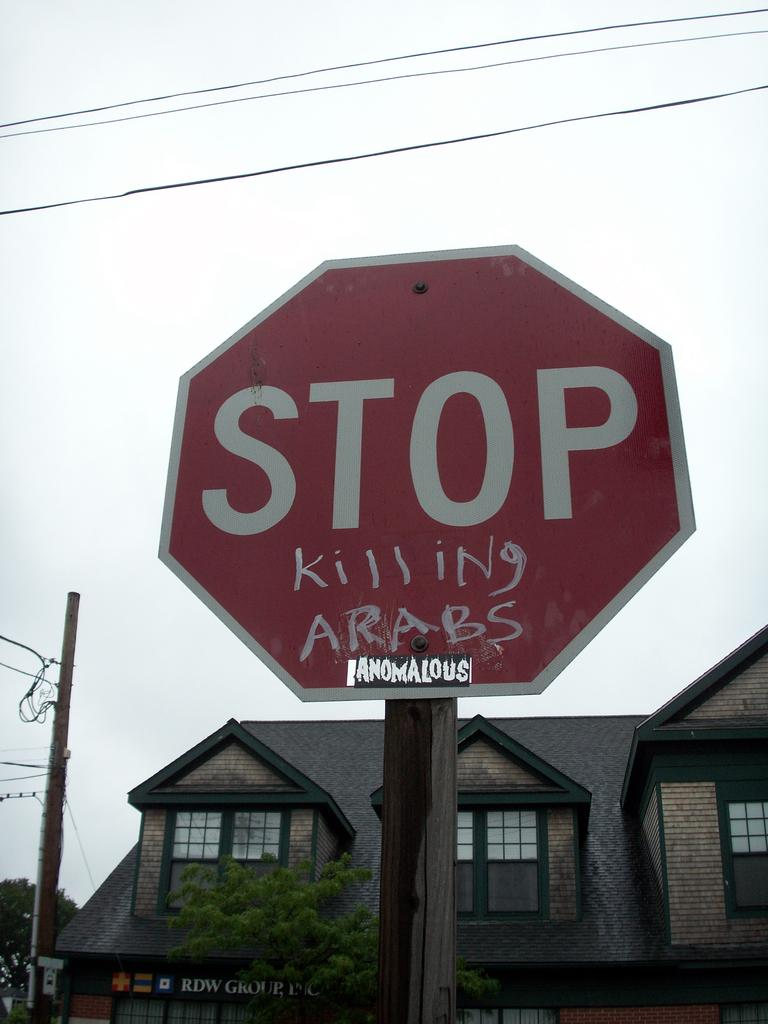<image>
Give a short and clear explanation of the subsequent image. A stop sign in front of the RDW Group building has graffiti on it. 